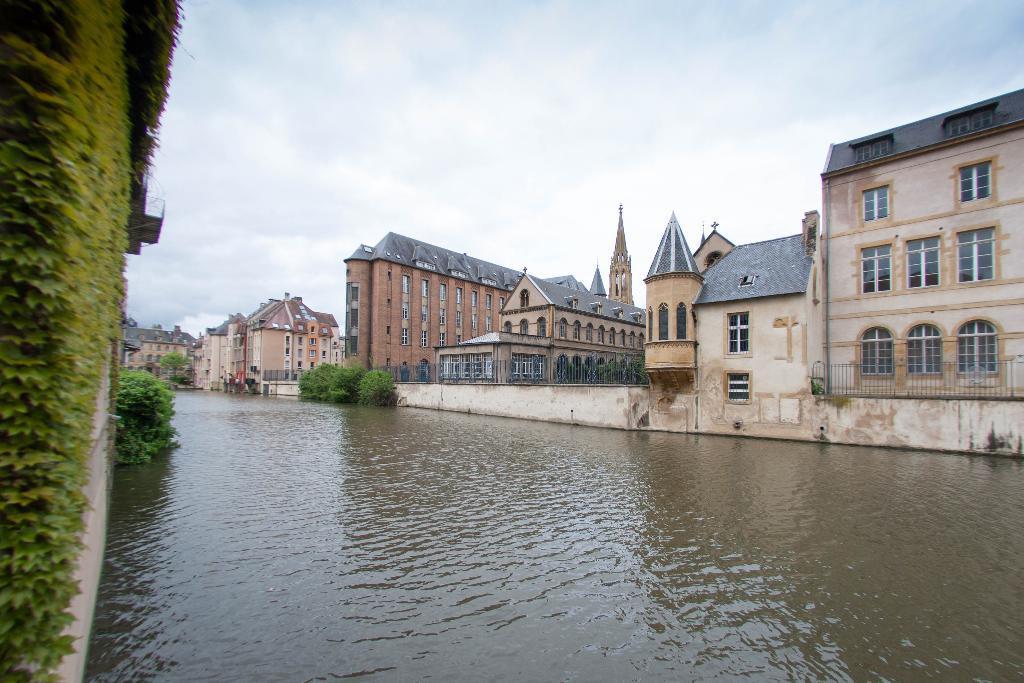How would you summarize this image in a sentence or two? Here we can see a plant on the wall and plants and there is water in the middle. In the background there are buildings,windows,fences,plants and clouds in the sky. 